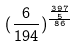Convert formula to latex. <formula><loc_0><loc_0><loc_500><loc_500>( \frac { 6 } { 1 9 4 } ) ^ { \frac { \frac { 3 9 7 } { 5 } } { 8 6 } }</formula> 